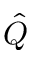Convert formula to latex. <formula><loc_0><loc_0><loc_500><loc_500>\hat { Q }</formula> 